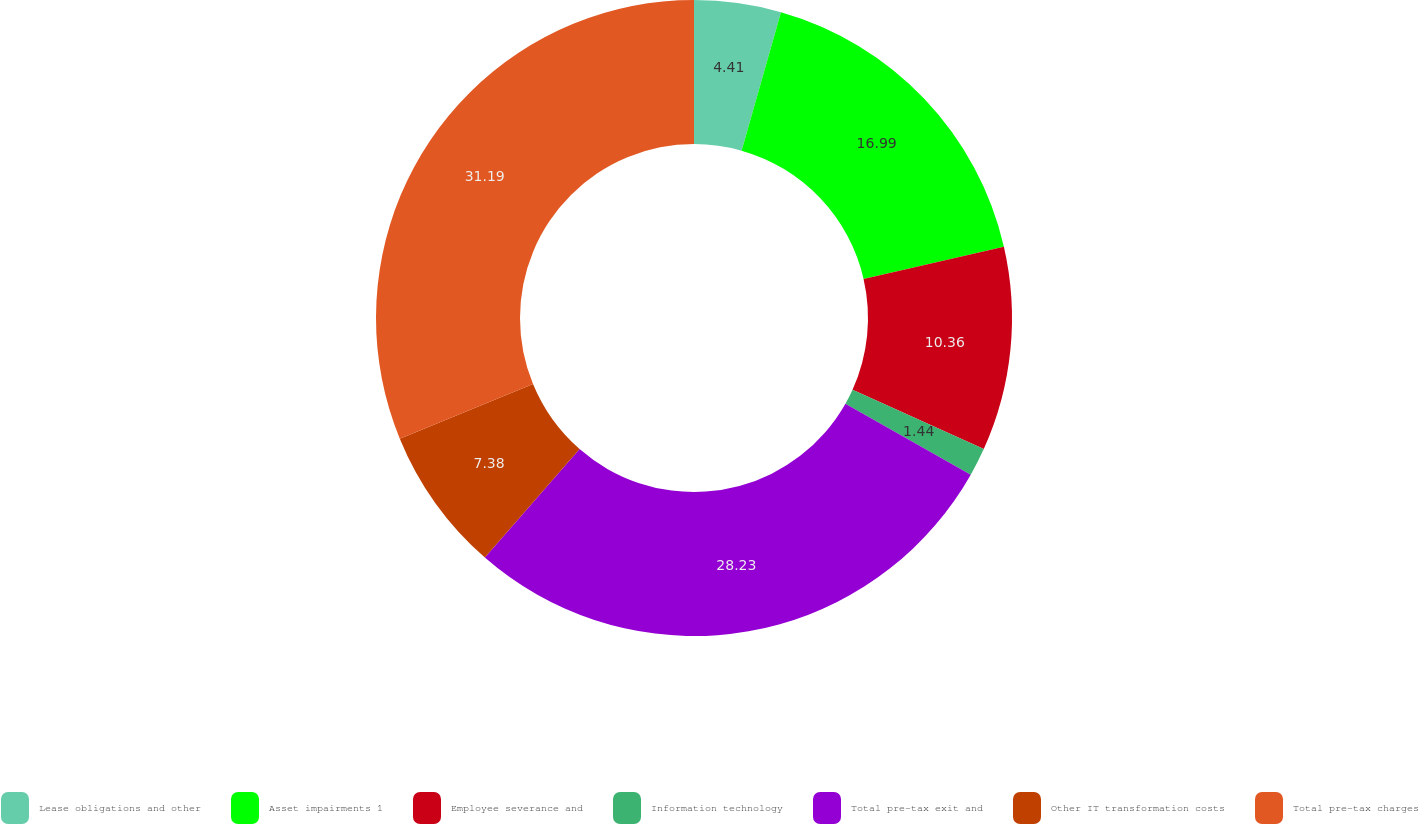Convert chart to OTSL. <chart><loc_0><loc_0><loc_500><loc_500><pie_chart><fcel>Lease obligations and other<fcel>Asset impairments 1<fcel>Employee severance and<fcel>Information technology<fcel>Total pre-tax exit and<fcel>Other IT transformation costs<fcel>Total pre-tax charges<nl><fcel>4.41%<fcel>16.99%<fcel>10.36%<fcel>1.44%<fcel>28.23%<fcel>7.38%<fcel>31.2%<nl></chart> 